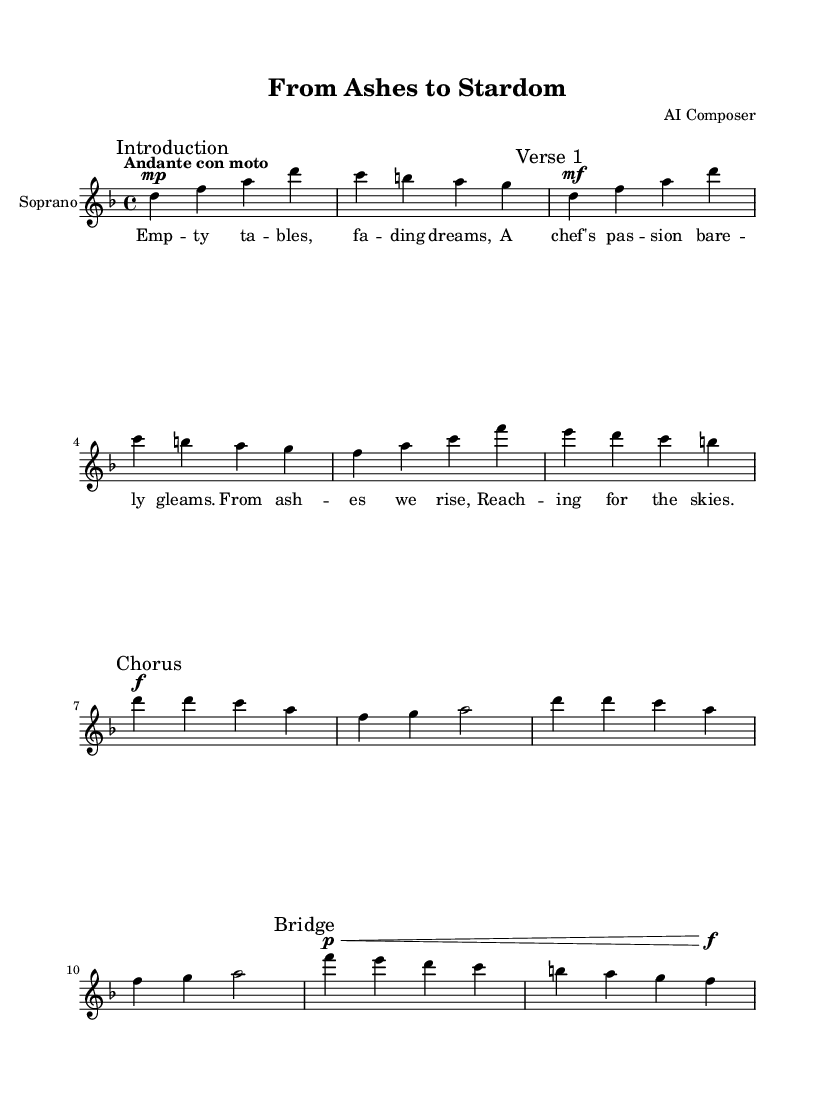What is the key signature of this music? The key signature is noted at the beginning of the piece and shows two flats, indicating it is in D minor.
Answer: D minor What is the time signature of this music? The time signature is located at the beginning of the score and is indicated as 4/4, which means there are four beats in each measure.
Answer: 4/4 What is the tempo marking of the piece? The tempo marking is specified right after the time signature, labeled as "Andante con moto," which indicates a moderate tempo with a slight increase in speed.
Answer: Andante con moto How many measures are in the introduction section? The introduction is represented at the start of the sheet music, which shows 4 measures before the first verse starts.
Answer: 4 measures What dynamic marking is used at the beginning of Verse 1? In the music notation for Verse 1, the dynamic marking is seen as "mf," which stands for mezzo-forte, indicating a moderately loud volume.
Answer: mezzo-forte What does the term "Chorus" indicate in this opera? The term "Chorus" appears in the sheet music, marking the transition to a repeated and often emotionally impactful section that typically includes the main theme of the opera.
Answer: Main theme section What are the emotions expressed in the lyrics of the first verse? The lyrics presented in Verse 1 convey a sense of despair and passion, highlighting the struggles of a chef and the emptiness of the restaurant.
Answer: Despair and passion 